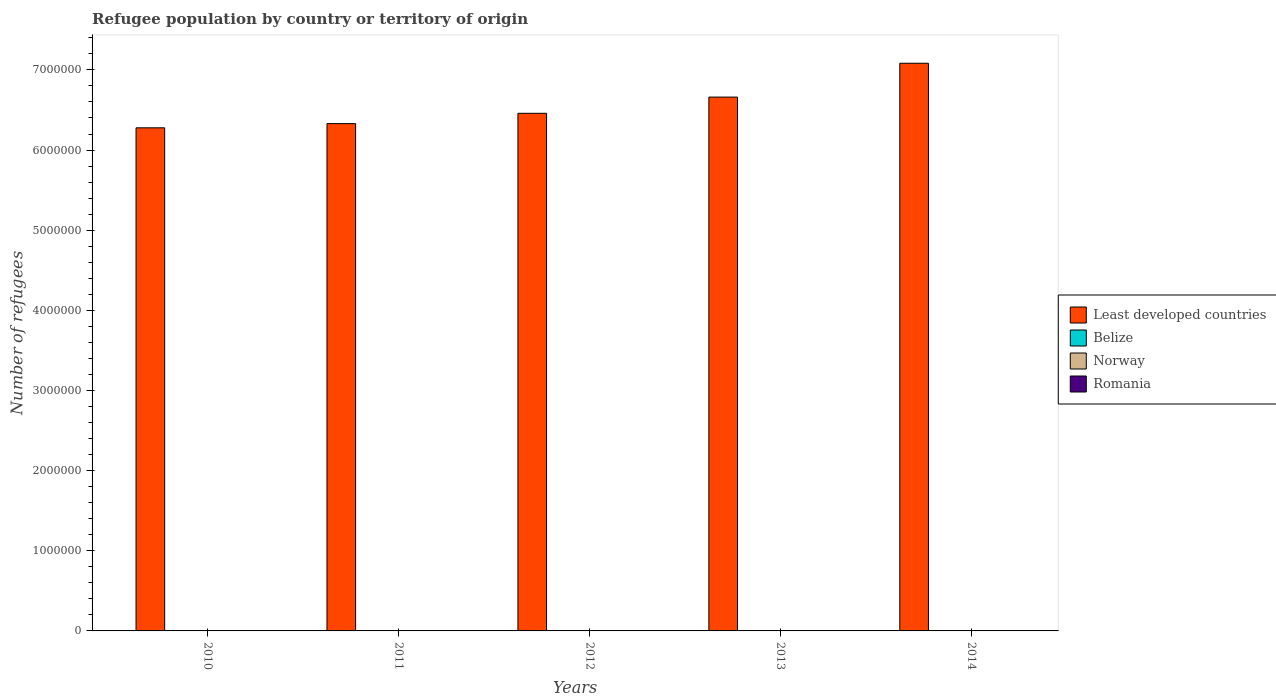How many different coloured bars are there?
Keep it short and to the point. 4. How many groups of bars are there?
Your answer should be compact. 5. Are the number of bars per tick equal to the number of legend labels?
Ensure brevity in your answer.  Yes. How many bars are there on the 5th tick from the left?
Offer a terse response. 4. How many bars are there on the 1st tick from the right?
Your answer should be very brief. 4. What is the label of the 3rd group of bars from the left?
Provide a short and direct response. 2012. What is the number of refugees in Romania in 2010?
Give a very brief answer. 3934. Across all years, what is the maximum number of refugees in Belize?
Provide a succinct answer. 45. In which year was the number of refugees in Romania maximum?
Offer a very short reply. 2010. What is the difference between the number of refugees in Least developed countries in 2010 and that in 2011?
Your answer should be compact. -5.23e+04. What is the difference between the number of refugees in Belize in 2011 and the number of refugees in Romania in 2013?
Your answer should be compact. -2297. What is the average number of refugees in Norway per year?
Your answer should be compact. 9.8. In the year 2011, what is the difference between the number of refugees in Romania and number of refugees in Least developed countries?
Give a very brief answer. -6.33e+06. In how many years, is the number of refugees in Belize greater than 4800000?
Offer a terse response. 0. What is the ratio of the number of refugees in Romania in 2010 to that in 2011?
Give a very brief answer. 1.15. Is the difference between the number of refugees in Romania in 2010 and 2011 greater than the difference between the number of refugees in Least developed countries in 2010 and 2011?
Make the answer very short. Yes. What is the difference between the highest and the second highest number of refugees in Romania?
Keep it short and to the point. 506. Is it the case that in every year, the sum of the number of refugees in Romania and number of refugees in Belize is greater than the sum of number of refugees in Norway and number of refugees in Least developed countries?
Your response must be concise. No. What does the 1st bar from the left in 2011 represents?
Your response must be concise. Least developed countries. Is it the case that in every year, the sum of the number of refugees in Least developed countries and number of refugees in Romania is greater than the number of refugees in Belize?
Offer a very short reply. Yes. How many bars are there?
Provide a succinct answer. 20. Are all the bars in the graph horizontal?
Your answer should be very brief. No. How many years are there in the graph?
Your answer should be very brief. 5. What is the difference between two consecutive major ticks on the Y-axis?
Your response must be concise. 1.00e+06. Are the values on the major ticks of Y-axis written in scientific E-notation?
Your response must be concise. No. Where does the legend appear in the graph?
Give a very brief answer. Center right. How many legend labels are there?
Ensure brevity in your answer.  4. What is the title of the graph?
Your answer should be very brief. Refugee population by country or territory of origin. Does "Honduras" appear as one of the legend labels in the graph?
Your answer should be compact. No. What is the label or title of the X-axis?
Provide a short and direct response. Years. What is the label or title of the Y-axis?
Your answer should be very brief. Number of refugees. What is the Number of refugees of Least developed countries in 2010?
Give a very brief answer. 6.28e+06. What is the Number of refugees of Norway in 2010?
Give a very brief answer. 7. What is the Number of refugees in Romania in 2010?
Your response must be concise. 3934. What is the Number of refugees of Least developed countries in 2011?
Keep it short and to the point. 6.33e+06. What is the Number of refugees of Belize in 2011?
Your response must be concise. 32. What is the Number of refugees in Norway in 2011?
Give a very brief answer. 7. What is the Number of refugees in Romania in 2011?
Give a very brief answer. 3428. What is the Number of refugees of Least developed countries in 2012?
Offer a very short reply. 6.46e+06. What is the Number of refugees of Norway in 2012?
Your answer should be very brief. 9. What is the Number of refugees in Romania in 2012?
Offer a terse response. 2807. What is the Number of refugees of Least developed countries in 2013?
Provide a succinct answer. 6.66e+06. What is the Number of refugees of Belize in 2013?
Offer a very short reply. 40. What is the Number of refugees of Norway in 2013?
Provide a succinct answer. 13. What is the Number of refugees in Romania in 2013?
Your answer should be very brief. 2329. What is the Number of refugees in Least developed countries in 2014?
Your answer should be very brief. 7.08e+06. What is the Number of refugees in Romania in 2014?
Ensure brevity in your answer.  1921. Across all years, what is the maximum Number of refugees in Least developed countries?
Provide a short and direct response. 7.08e+06. Across all years, what is the maximum Number of refugees in Romania?
Offer a very short reply. 3934. Across all years, what is the minimum Number of refugees in Least developed countries?
Make the answer very short. 6.28e+06. Across all years, what is the minimum Number of refugees in Norway?
Provide a succinct answer. 7. Across all years, what is the minimum Number of refugees of Romania?
Offer a terse response. 1921. What is the total Number of refugees in Least developed countries in the graph?
Your response must be concise. 3.28e+07. What is the total Number of refugees of Belize in the graph?
Give a very brief answer. 179. What is the total Number of refugees of Romania in the graph?
Ensure brevity in your answer.  1.44e+04. What is the difference between the Number of refugees of Least developed countries in 2010 and that in 2011?
Your answer should be compact. -5.23e+04. What is the difference between the Number of refugees of Romania in 2010 and that in 2011?
Your answer should be very brief. 506. What is the difference between the Number of refugees in Least developed countries in 2010 and that in 2012?
Make the answer very short. -1.81e+05. What is the difference between the Number of refugees of Belize in 2010 and that in 2012?
Make the answer very short. -16. What is the difference between the Number of refugees of Romania in 2010 and that in 2012?
Provide a succinct answer. 1127. What is the difference between the Number of refugees in Least developed countries in 2010 and that in 2013?
Keep it short and to the point. -3.83e+05. What is the difference between the Number of refugees of Norway in 2010 and that in 2013?
Give a very brief answer. -6. What is the difference between the Number of refugees of Romania in 2010 and that in 2013?
Ensure brevity in your answer.  1605. What is the difference between the Number of refugees in Least developed countries in 2010 and that in 2014?
Your answer should be compact. -8.05e+05. What is the difference between the Number of refugees of Belize in 2010 and that in 2014?
Your answer should be compact. -22. What is the difference between the Number of refugees in Norway in 2010 and that in 2014?
Make the answer very short. -6. What is the difference between the Number of refugees of Romania in 2010 and that in 2014?
Offer a terse response. 2013. What is the difference between the Number of refugees of Least developed countries in 2011 and that in 2012?
Your answer should be compact. -1.29e+05. What is the difference between the Number of refugees in Belize in 2011 and that in 2012?
Make the answer very short. -7. What is the difference between the Number of refugees of Romania in 2011 and that in 2012?
Make the answer very short. 621. What is the difference between the Number of refugees in Least developed countries in 2011 and that in 2013?
Make the answer very short. -3.31e+05. What is the difference between the Number of refugees in Romania in 2011 and that in 2013?
Offer a terse response. 1099. What is the difference between the Number of refugees of Least developed countries in 2011 and that in 2014?
Offer a very short reply. -7.53e+05. What is the difference between the Number of refugees in Norway in 2011 and that in 2014?
Your answer should be very brief. -6. What is the difference between the Number of refugees in Romania in 2011 and that in 2014?
Make the answer very short. 1507. What is the difference between the Number of refugees in Least developed countries in 2012 and that in 2013?
Offer a terse response. -2.02e+05. What is the difference between the Number of refugees in Romania in 2012 and that in 2013?
Your response must be concise. 478. What is the difference between the Number of refugees of Least developed countries in 2012 and that in 2014?
Provide a succinct answer. -6.24e+05. What is the difference between the Number of refugees in Belize in 2012 and that in 2014?
Your answer should be compact. -6. What is the difference between the Number of refugees in Norway in 2012 and that in 2014?
Your answer should be compact. -4. What is the difference between the Number of refugees in Romania in 2012 and that in 2014?
Offer a terse response. 886. What is the difference between the Number of refugees of Least developed countries in 2013 and that in 2014?
Make the answer very short. -4.22e+05. What is the difference between the Number of refugees of Norway in 2013 and that in 2014?
Keep it short and to the point. 0. What is the difference between the Number of refugees in Romania in 2013 and that in 2014?
Offer a very short reply. 408. What is the difference between the Number of refugees of Least developed countries in 2010 and the Number of refugees of Belize in 2011?
Your answer should be very brief. 6.28e+06. What is the difference between the Number of refugees of Least developed countries in 2010 and the Number of refugees of Norway in 2011?
Your answer should be very brief. 6.28e+06. What is the difference between the Number of refugees in Least developed countries in 2010 and the Number of refugees in Romania in 2011?
Keep it short and to the point. 6.27e+06. What is the difference between the Number of refugees in Belize in 2010 and the Number of refugees in Norway in 2011?
Make the answer very short. 16. What is the difference between the Number of refugees in Belize in 2010 and the Number of refugees in Romania in 2011?
Provide a succinct answer. -3405. What is the difference between the Number of refugees of Norway in 2010 and the Number of refugees of Romania in 2011?
Provide a succinct answer. -3421. What is the difference between the Number of refugees of Least developed countries in 2010 and the Number of refugees of Belize in 2012?
Keep it short and to the point. 6.28e+06. What is the difference between the Number of refugees in Least developed countries in 2010 and the Number of refugees in Norway in 2012?
Give a very brief answer. 6.28e+06. What is the difference between the Number of refugees of Least developed countries in 2010 and the Number of refugees of Romania in 2012?
Keep it short and to the point. 6.27e+06. What is the difference between the Number of refugees in Belize in 2010 and the Number of refugees in Romania in 2012?
Provide a succinct answer. -2784. What is the difference between the Number of refugees of Norway in 2010 and the Number of refugees of Romania in 2012?
Make the answer very short. -2800. What is the difference between the Number of refugees in Least developed countries in 2010 and the Number of refugees in Belize in 2013?
Your response must be concise. 6.28e+06. What is the difference between the Number of refugees in Least developed countries in 2010 and the Number of refugees in Norway in 2013?
Your answer should be very brief. 6.28e+06. What is the difference between the Number of refugees of Least developed countries in 2010 and the Number of refugees of Romania in 2013?
Offer a very short reply. 6.28e+06. What is the difference between the Number of refugees of Belize in 2010 and the Number of refugees of Romania in 2013?
Give a very brief answer. -2306. What is the difference between the Number of refugees in Norway in 2010 and the Number of refugees in Romania in 2013?
Make the answer very short. -2322. What is the difference between the Number of refugees in Least developed countries in 2010 and the Number of refugees in Belize in 2014?
Provide a short and direct response. 6.28e+06. What is the difference between the Number of refugees in Least developed countries in 2010 and the Number of refugees in Norway in 2014?
Your answer should be compact. 6.28e+06. What is the difference between the Number of refugees of Least developed countries in 2010 and the Number of refugees of Romania in 2014?
Give a very brief answer. 6.28e+06. What is the difference between the Number of refugees of Belize in 2010 and the Number of refugees of Romania in 2014?
Provide a short and direct response. -1898. What is the difference between the Number of refugees of Norway in 2010 and the Number of refugees of Romania in 2014?
Your answer should be very brief. -1914. What is the difference between the Number of refugees of Least developed countries in 2011 and the Number of refugees of Belize in 2012?
Offer a terse response. 6.33e+06. What is the difference between the Number of refugees of Least developed countries in 2011 and the Number of refugees of Norway in 2012?
Offer a very short reply. 6.33e+06. What is the difference between the Number of refugees of Least developed countries in 2011 and the Number of refugees of Romania in 2012?
Offer a terse response. 6.33e+06. What is the difference between the Number of refugees of Belize in 2011 and the Number of refugees of Romania in 2012?
Offer a terse response. -2775. What is the difference between the Number of refugees of Norway in 2011 and the Number of refugees of Romania in 2012?
Offer a very short reply. -2800. What is the difference between the Number of refugees of Least developed countries in 2011 and the Number of refugees of Belize in 2013?
Offer a very short reply. 6.33e+06. What is the difference between the Number of refugees in Least developed countries in 2011 and the Number of refugees in Norway in 2013?
Your answer should be very brief. 6.33e+06. What is the difference between the Number of refugees in Least developed countries in 2011 and the Number of refugees in Romania in 2013?
Provide a succinct answer. 6.33e+06. What is the difference between the Number of refugees of Belize in 2011 and the Number of refugees of Norway in 2013?
Your answer should be compact. 19. What is the difference between the Number of refugees in Belize in 2011 and the Number of refugees in Romania in 2013?
Your response must be concise. -2297. What is the difference between the Number of refugees of Norway in 2011 and the Number of refugees of Romania in 2013?
Provide a short and direct response. -2322. What is the difference between the Number of refugees in Least developed countries in 2011 and the Number of refugees in Belize in 2014?
Ensure brevity in your answer.  6.33e+06. What is the difference between the Number of refugees of Least developed countries in 2011 and the Number of refugees of Norway in 2014?
Give a very brief answer. 6.33e+06. What is the difference between the Number of refugees of Least developed countries in 2011 and the Number of refugees of Romania in 2014?
Provide a succinct answer. 6.33e+06. What is the difference between the Number of refugees of Belize in 2011 and the Number of refugees of Romania in 2014?
Keep it short and to the point. -1889. What is the difference between the Number of refugees in Norway in 2011 and the Number of refugees in Romania in 2014?
Provide a short and direct response. -1914. What is the difference between the Number of refugees in Least developed countries in 2012 and the Number of refugees in Belize in 2013?
Offer a very short reply. 6.46e+06. What is the difference between the Number of refugees in Least developed countries in 2012 and the Number of refugees in Norway in 2013?
Ensure brevity in your answer.  6.46e+06. What is the difference between the Number of refugees in Least developed countries in 2012 and the Number of refugees in Romania in 2013?
Give a very brief answer. 6.46e+06. What is the difference between the Number of refugees in Belize in 2012 and the Number of refugees in Norway in 2013?
Your answer should be compact. 26. What is the difference between the Number of refugees of Belize in 2012 and the Number of refugees of Romania in 2013?
Offer a very short reply. -2290. What is the difference between the Number of refugees of Norway in 2012 and the Number of refugees of Romania in 2013?
Provide a succinct answer. -2320. What is the difference between the Number of refugees in Least developed countries in 2012 and the Number of refugees in Belize in 2014?
Provide a succinct answer. 6.46e+06. What is the difference between the Number of refugees of Least developed countries in 2012 and the Number of refugees of Norway in 2014?
Make the answer very short. 6.46e+06. What is the difference between the Number of refugees in Least developed countries in 2012 and the Number of refugees in Romania in 2014?
Your response must be concise. 6.46e+06. What is the difference between the Number of refugees of Belize in 2012 and the Number of refugees of Norway in 2014?
Provide a short and direct response. 26. What is the difference between the Number of refugees of Belize in 2012 and the Number of refugees of Romania in 2014?
Your response must be concise. -1882. What is the difference between the Number of refugees of Norway in 2012 and the Number of refugees of Romania in 2014?
Your answer should be compact. -1912. What is the difference between the Number of refugees of Least developed countries in 2013 and the Number of refugees of Belize in 2014?
Offer a very short reply. 6.66e+06. What is the difference between the Number of refugees of Least developed countries in 2013 and the Number of refugees of Norway in 2014?
Offer a very short reply. 6.66e+06. What is the difference between the Number of refugees of Least developed countries in 2013 and the Number of refugees of Romania in 2014?
Give a very brief answer. 6.66e+06. What is the difference between the Number of refugees in Belize in 2013 and the Number of refugees in Romania in 2014?
Provide a short and direct response. -1881. What is the difference between the Number of refugees in Norway in 2013 and the Number of refugees in Romania in 2014?
Offer a terse response. -1908. What is the average Number of refugees in Least developed countries per year?
Your answer should be very brief. 6.56e+06. What is the average Number of refugees in Belize per year?
Provide a succinct answer. 35.8. What is the average Number of refugees of Romania per year?
Offer a terse response. 2883.8. In the year 2010, what is the difference between the Number of refugees in Least developed countries and Number of refugees in Belize?
Your answer should be compact. 6.28e+06. In the year 2010, what is the difference between the Number of refugees in Least developed countries and Number of refugees in Norway?
Give a very brief answer. 6.28e+06. In the year 2010, what is the difference between the Number of refugees in Least developed countries and Number of refugees in Romania?
Provide a short and direct response. 6.27e+06. In the year 2010, what is the difference between the Number of refugees of Belize and Number of refugees of Norway?
Keep it short and to the point. 16. In the year 2010, what is the difference between the Number of refugees of Belize and Number of refugees of Romania?
Your response must be concise. -3911. In the year 2010, what is the difference between the Number of refugees of Norway and Number of refugees of Romania?
Offer a terse response. -3927. In the year 2011, what is the difference between the Number of refugees in Least developed countries and Number of refugees in Belize?
Make the answer very short. 6.33e+06. In the year 2011, what is the difference between the Number of refugees of Least developed countries and Number of refugees of Norway?
Provide a short and direct response. 6.33e+06. In the year 2011, what is the difference between the Number of refugees in Least developed countries and Number of refugees in Romania?
Your answer should be compact. 6.33e+06. In the year 2011, what is the difference between the Number of refugees in Belize and Number of refugees in Norway?
Your answer should be compact. 25. In the year 2011, what is the difference between the Number of refugees in Belize and Number of refugees in Romania?
Keep it short and to the point. -3396. In the year 2011, what is the difference between the Number of refugees in Norway and Number of refugees in Romania?
Give a very brief answer. -3421. In the year 2012, what is the difference between the Number of refugees of Least developed countries and Number of refugees of Belize?
Your answer should be compact. 6.46e+06. In the year 2012, what is the difference between the Number of refugees in Least developed countries and Number of refugees in Norway?
Provide a short and direct response. 6.46e+06. In the year 2012, what is the difference between the Number of refugees in Least developed countries and Number of refugees in Romania?
Keep it short and to the point. 6.46e+06. In the year 2012, what is the difference between the Number of refugees of Belize and Number of refugees of Norway?
Provide a succinct answer. 30. In the year 2012, what is the difference between the Number of refugees of Belize and Number of refugees of Romania?
Provide a short and direct response. -2768. In the year 2012, what is the difference between the Number of refugees of Norway and Number of refugees of Romania?
Provide a succinct answer. -2798. In the year 2013, what is the difference between the Number of refugees in Least developed countries and Number of refugees in Belize?
Your answer should be very brief. 6.66e+06. In the year 2013, what is the difference between the Number of refugees of Least developed countries and Number of refugees of Norway?
Your answer should be very brief. 6.66e+06. In the year 2013, what is the difference between the Number of refugees in Least developed countries and Number of refugees in Romania?
Your answer should be very brief. 6.66e+06. In the year 2013, what is the difference between the Number of refugees of Belize and Number of refugees of Norway?
Keep it short and to the point. 27. In the year 2013, what is the difference between the Number of refugees of Belize and Number of refugees of Romania?
Provide a succinct answer. -2289. In the year 2013, what is the difference between the Number of refugees of Norway and Number of refugees of Romania?
Your answer should be compact. -2316. In the year 2014, what is the difference between the Number of refugees of Least developed countries and Number of refugees of Belize?
Make the answer very short. 7.08e+06. In the year 2014, what is the difference between the Number of refugees in Least developed countries and Number of refugees in Norway?
Your response must be concise. 7.08e+06. In the year 2014, what is the difference between the Number of refugees of Least developed countries and Number of refugees of Romania?
Make the answer very short. 7.08e+06. In the year 2014, what is the difference between the Number of refugees of Belize and Number of refugees of Norway?
Provide a short and direct response. 32. In the year 2014, what is the difference between the Number of refugees of Belize and Number of refugees of Romania?
Make the answer very short. -1876. In the year 2014, what is the difference between the Number of refugees of Norway and Number of refugees of Romania?
Ensure brevity in your answer.  -1908. What is the ratio of the Number of refugees of Belize in 2010 to that in 2011?
Make the answer very short. 0.72. What is the ratio of the Number of refugees of Norway in 2010 to that in 2011?
Provide a succinct answer. 1. What is the ratio of the Number of refugees of Romania in 2010 to that in 2011?
Your answer should be very brief. 1.15. What is the ratio of the Number of refugees of Belize in 2010 to that in 2012?
Give a very brief answer. 0.59. What is the ratio of the Number of refugees in Romania in 2010 to that in 2012?
Make the answer very short. 1.4. What is the ratio of the Number of refugees in Least developed countries in 2010 to that in 2013?
Your answer should be compact. 0.94. What is the ratio of the Number of refugees of Belize in 2010 to that in 2013?
Provide a succinct answer. 0.57. What is the ratio of the Number of refugees in Norway in 2010 to that in 2013?
Provide a short and direct response. 0.54. What is the ratio of the Number of refugees of Romania in 2010 to that in 2013?
Keep it short and to the point. 1.69. What is the ratio of the Number of refugees of Least developed countries in 2010 to that in 2014?
Your answer should be very brief. 0.89. What is the ratio of the Number of refugees of Belize in 2010 to that in 2014?
Ensure brevity in your answer.  0.51. What is the ratio of the Number of refugees in Norway in 2010 to that in 2014?
Your answer should be very brief. 0.54. What is the ratio of the Number of refugees in Romania in 2010 to that in 2014?
Your answer should be very brief. 2.05. What is the ratio of the Number of refugees of Least developed countries in 2011 to that in 2012?
Offer a very short reply. 0.98. What is the ratio of the Number of refugees in Belize in 2011 to that in 2012?
Provide a short and direct response. 0.82. What is the ratio of the Number of refugees in Norway in 2011 to that in 2012?
Offer a very short reply. 0.78. What is the ratio of the Number of refugees of Romania in 2011 to that in 2012?
Your answer should be compact. 1.22. What is the ratio of the Number of refugees in Least developed countries in 2011 to that in 2013?
Make the answer very short. 0.95. What is the ratio of the Number of refugees of Norway in 2011 to that in 2013?
Your answer should be compact. 0.54. What is the ratio of the Number of refugees in Romania in 2011 to that in 2013?
Ensure brevity in your answer.  1.47. What is the ratio of the Number of refugees of Least developed countries in 2011 to that in 2014?
Offer a very short reply. 0.89. What is the ratio of the Number of refugees of Belize in 2011 to that in 2014?
Keep it short and to the point. 0.71. What is the ratio of the Number of refugees of Norway in 2011 to that in 2014?
Give a very brief answer. 0.54. What is the ratio of the Number of refugees in Romania in 2011 to that in 2014?
Make the answer very short. 1.78. What is the ratio of the Number of refugees of Least developed countries in 2012 to that in 2013?
Your response must be concise. 0.97. What is the ratio of the Number of refugees in Norway in 2012 to that in 2013?
Give a very brief answer. 0.69. What is the ratio of the Number of refugees in Romania in 2012 to that in 2013?
Provide a succinct answer. 1.21. What is the ratio of the Number of refugees in Least developed countries in 2012 to that in 2014?
Your answer should be compact. 0.91. What is the ratio of the Number of refugees of Belize in 2012 to that in 2014?
Make the answer very short. 0.87. What is the ratio of the Number of refugees in Norway in 2012 to that in 2014?
Provide a short and direct response. 0.69. What is the ratio of the Number of refugees in Romania in 2012 to that in 2014?
Make the answer very short. 1.46. What is the ratio of the Number of refugees of Least developed countries in 2013 to that in 2014?
Your response must be concise. 0.94. What is the ratio of the Number of refugees of Romania in 2013 to that in 2014?
Ensure brevity in your answer.  1.21. What is the difference between the highest and the second highest Number of refugees in Least developed countries?
Make the answer very short. 4.22e+05. What is the difference between the highest and the second highest Number of refugees of Norway?
Keep it short and to the point. 0. What is the difference between the highest and the second highest Number of refugees in Romania?
Provide a succinct answer. 506. What is the difference between the highest and the lowest Number of refugees of Least developed countries?
Your answer should be very brief. 8.05e+05. What is the difference between the highest and the lowest Number of refugees in Belize?
Offer a very short reply. 22. What is the difference between the highest and the lowest Number of refugees in Romania?
Your answer should be compact. 2013. 